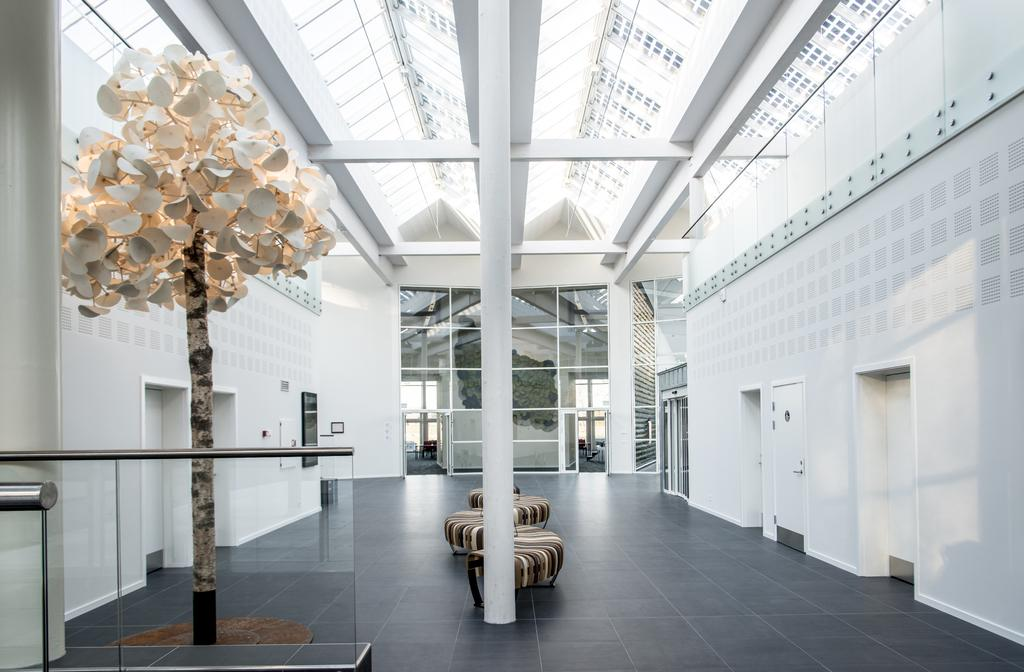What type of surface is visible in the image? There is a floor in the image. What type of furniture is present in the image? There is a sofa set in the image. What architectural elements can be seen in the image? There are poles, doors, and walls in the image. What reflective object is present in the image? There is a mirror in the image. What type of glove is being used to clean the mirror in the image? There is no glove present in the image, and the mirror is not being cleaned. 